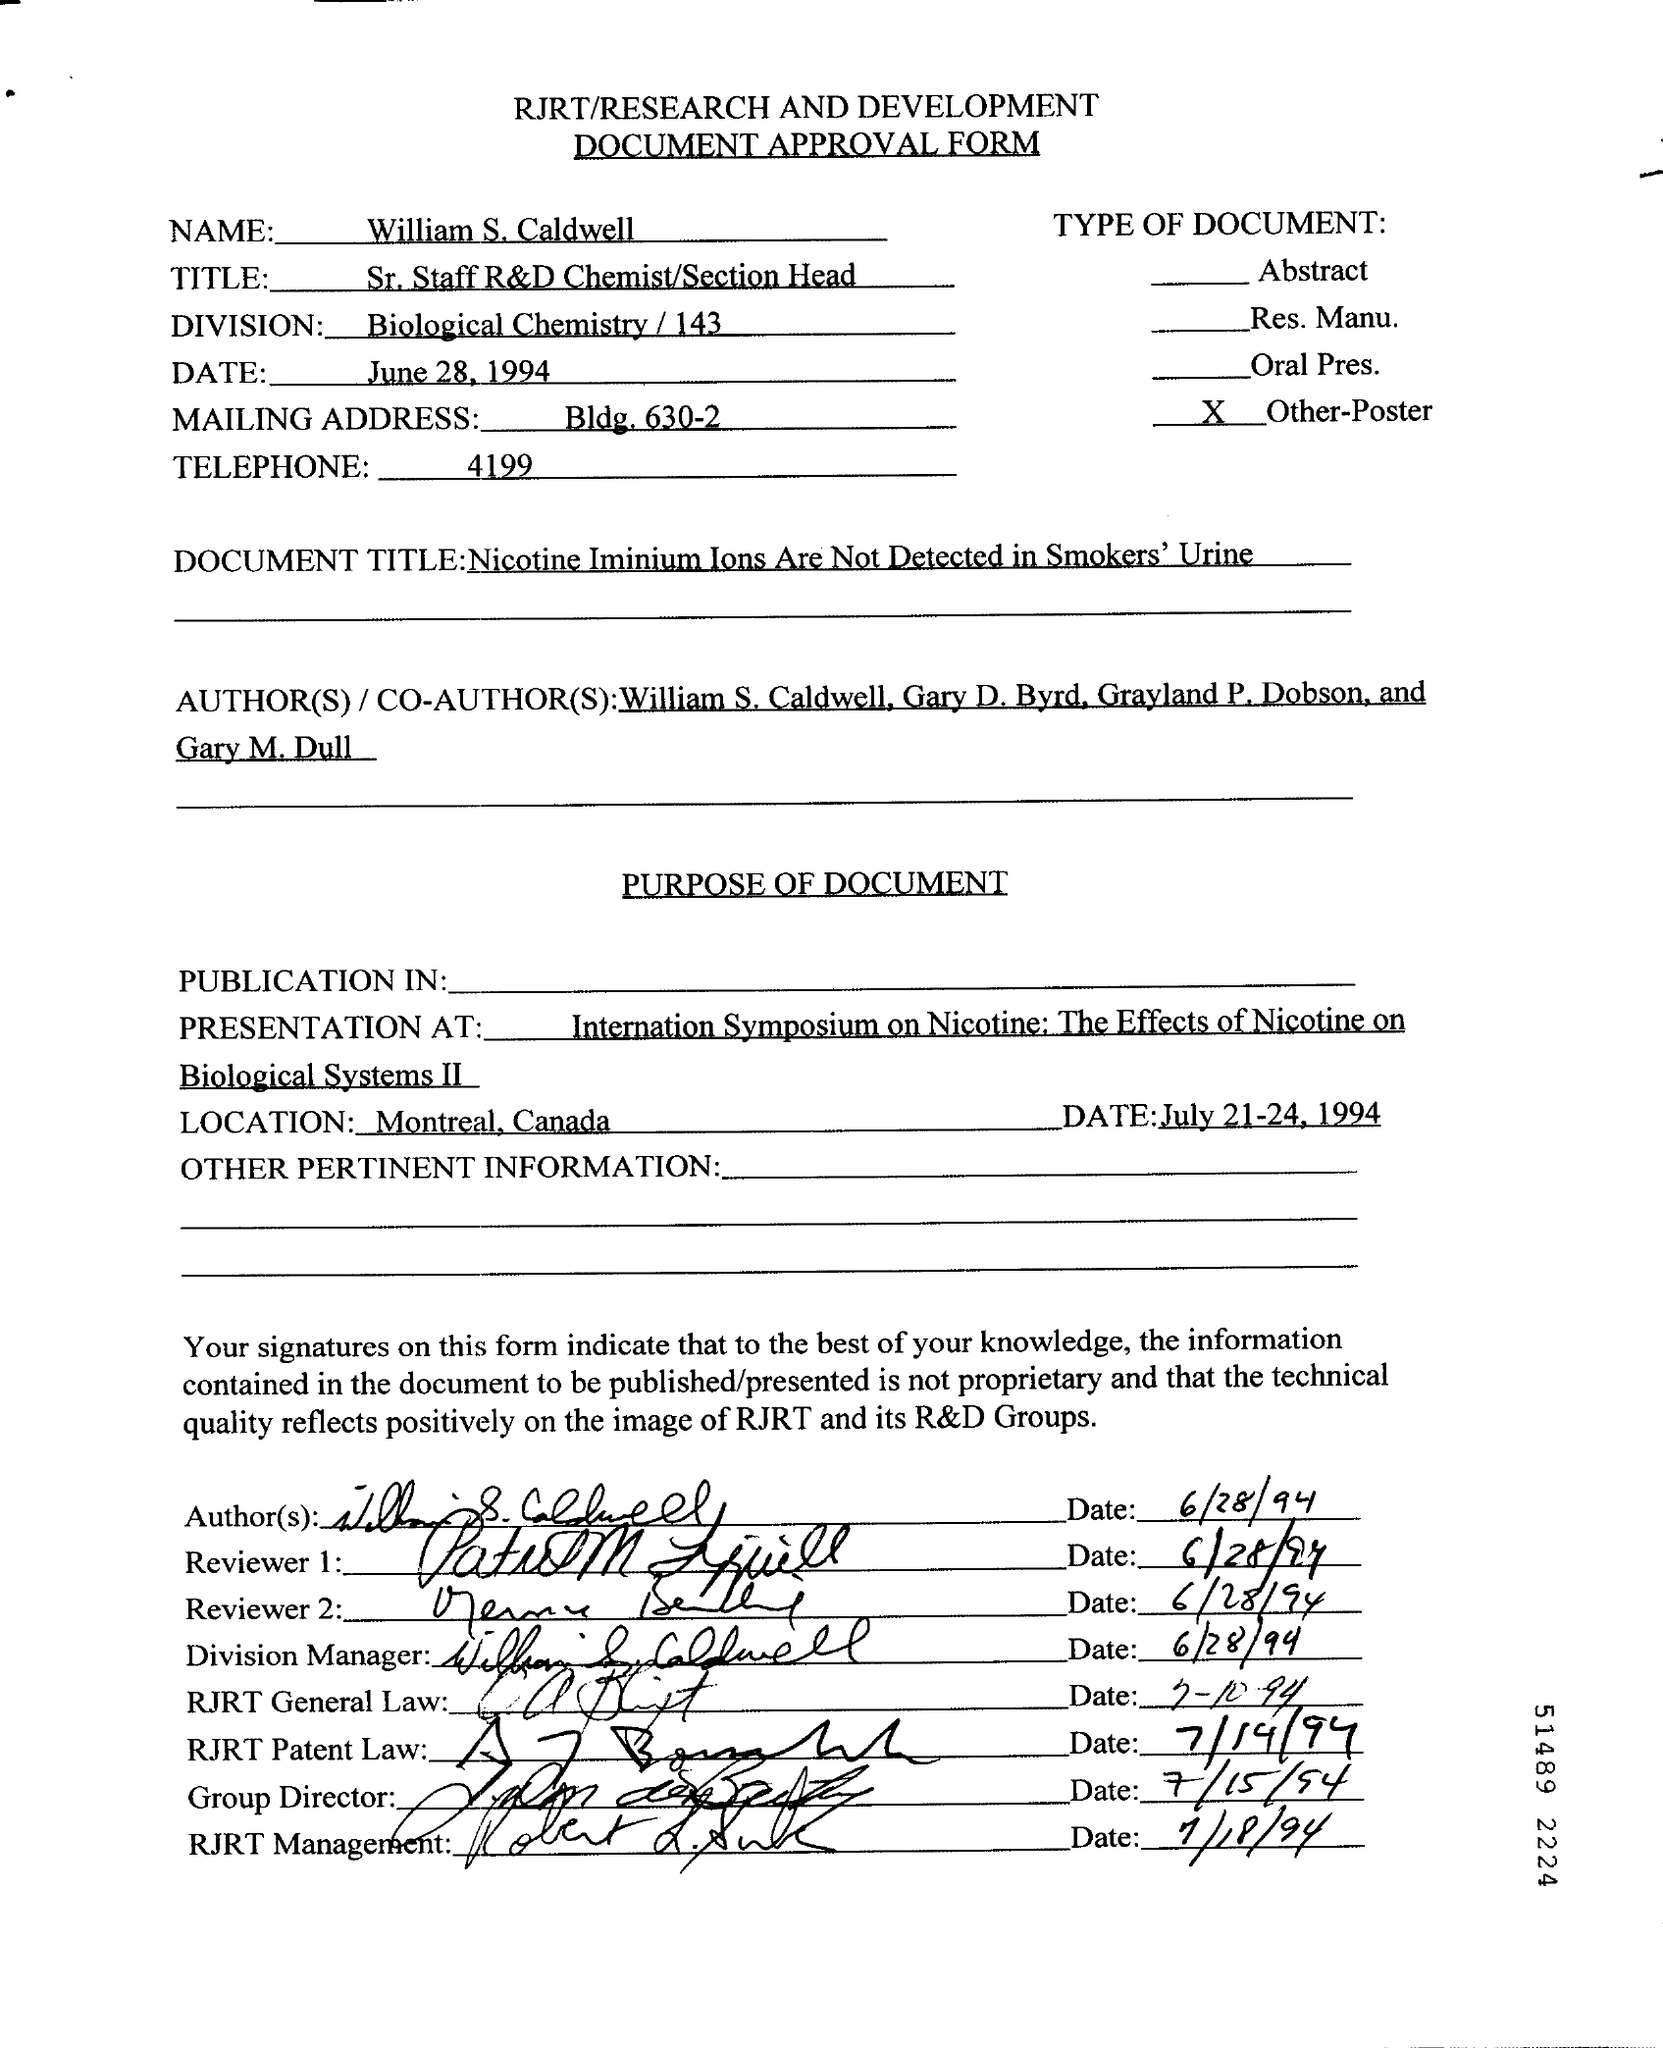What is written in the Division field ?
Offer a terse response. Biological Chemistry / 143. What is the date mentioned in the top of the document ?
Give a very brief answer. June 28, 1994. What is the Telephone Number ?
Give a very brief answer. 4199. Where is the Location ?
Your answer should be very brief. Montreal. 